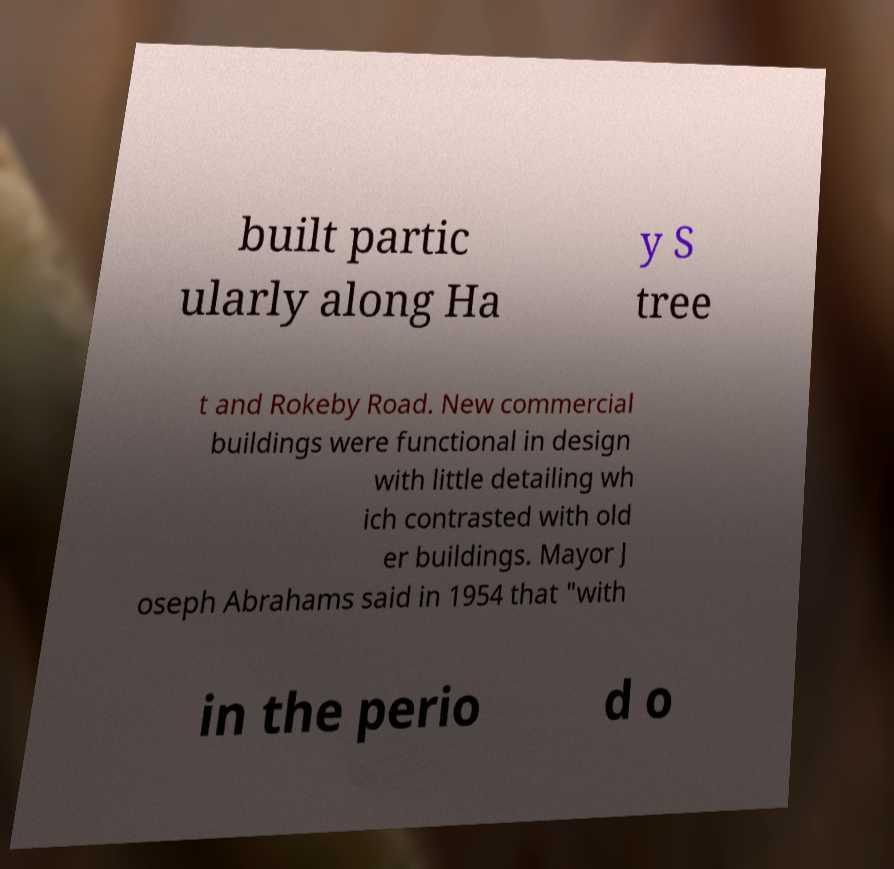I need the written content from this picture converted into text. Can you do that? built partic ularly along Ha y S tree t and Rokeby Road. New commercial buildings were functional in design with little detailing wh ich contrasted with old er buildings. Mayor J oseph Abrahams said in 1954 that "with in the perio d o 